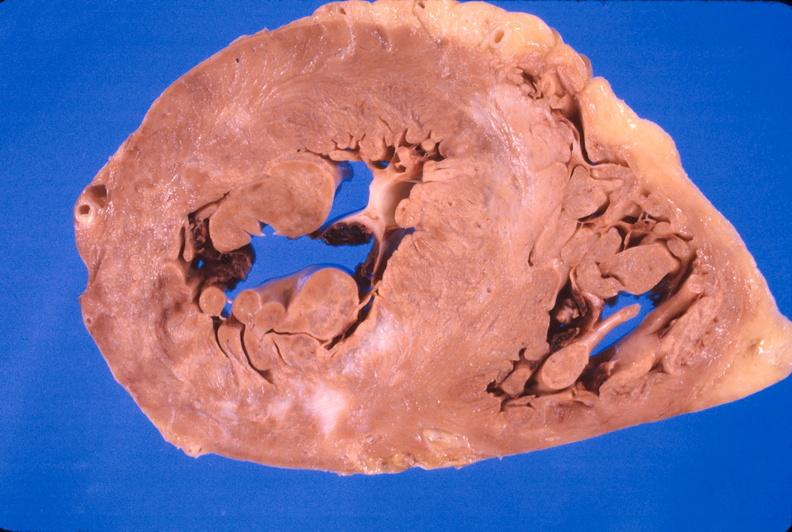where is this?
Answer the question using a single word or phrase. Heart 